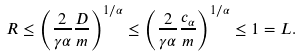Convert formula to latex. <formula><loc_0><loc_0><loc_500><loc_500>R \leq \left ( \frac { 2 } { \gamma \alpha } \frac { D } { m } \right ) ^ { 1 / \alpha } \leq \left ( \frac { 2 } { \gamma \alpha } \frac { c _ { \alpha } } { m } \right ) ^ { 1 / \alpha } \leq 1 = L .</formula> 